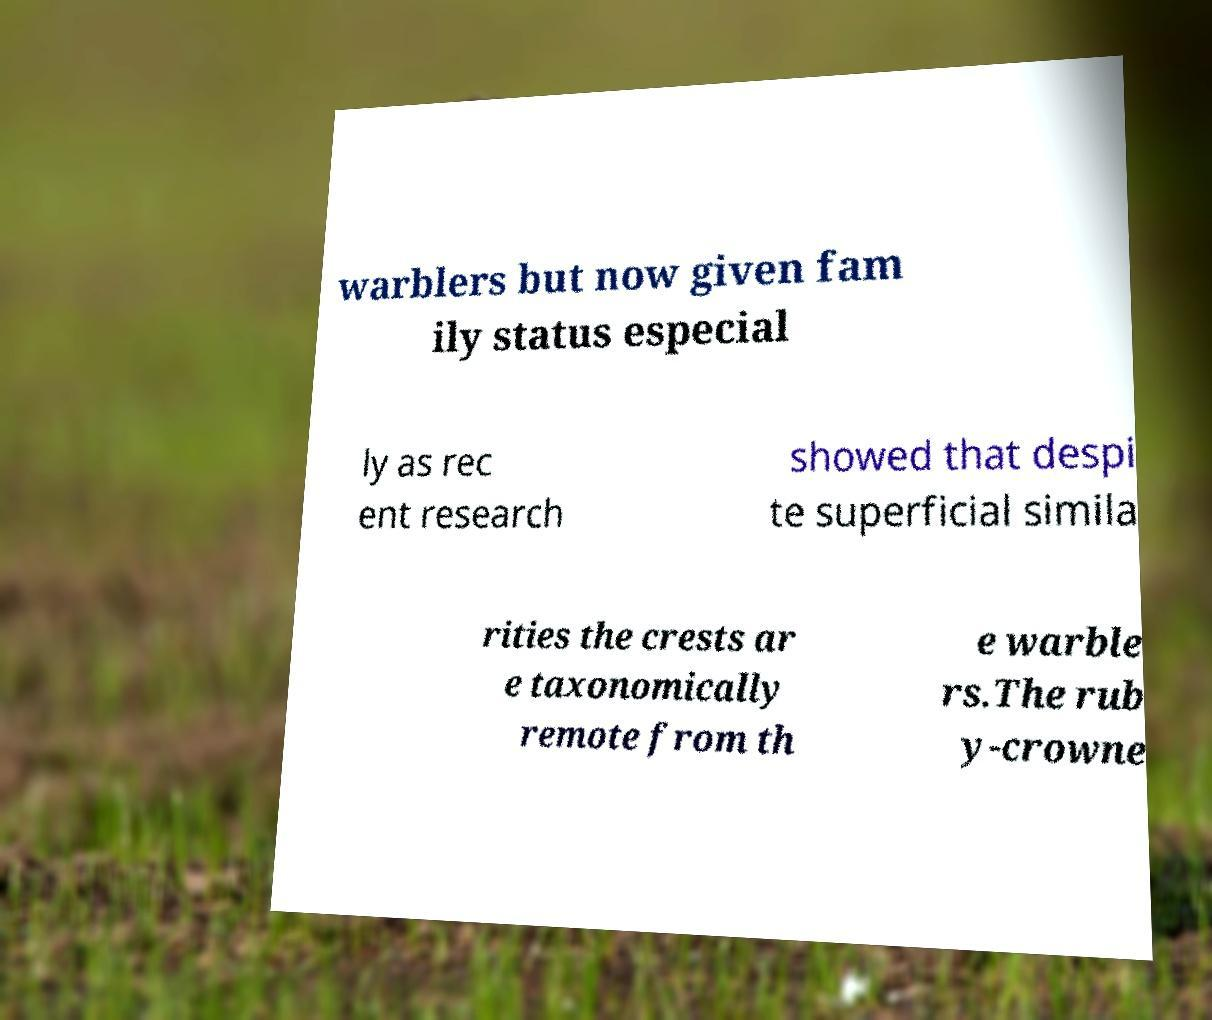For documentation purposes, I need the text within this image transcribed. Could you provide that? warblers but now given fam ily status especial ly as rec ent research showed that despi te superficial simila rities the crests ar e taxonomically remote from th e warble rs.The rub y-crowne 